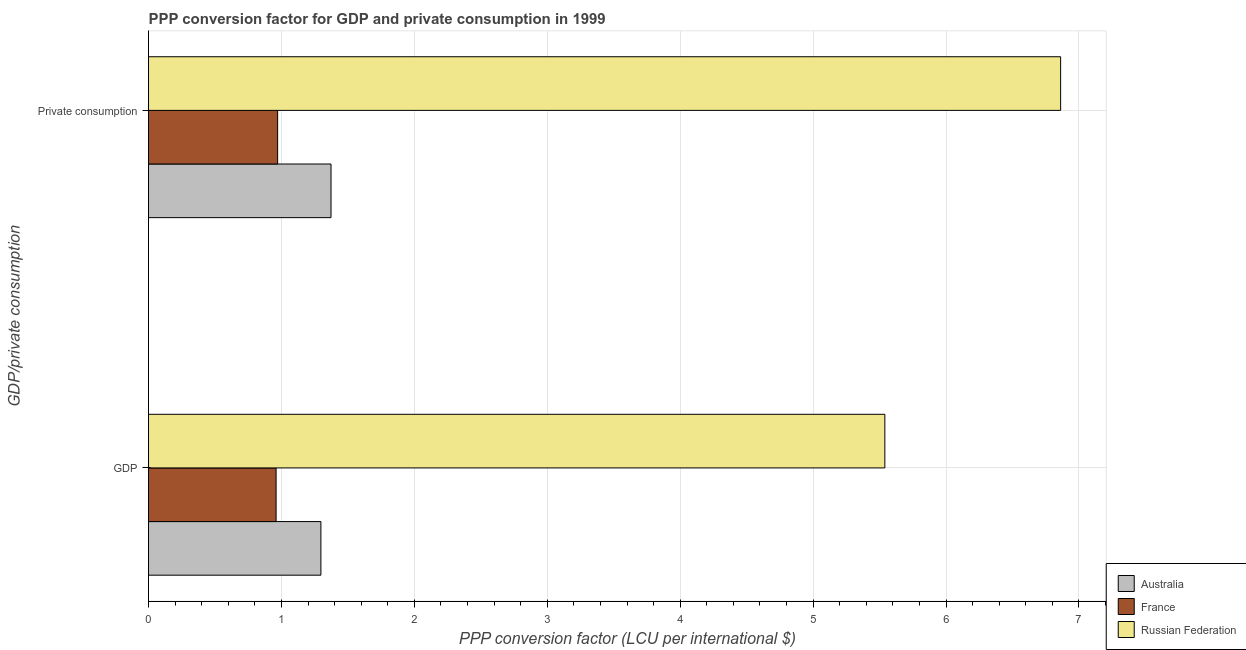How many groups of bars are there?
Your answer should be very brief. 2. Are the number of bars per tick equal to the number of legend labels?
Make the answer very short. Yes. How many bars are there on the 1st tick from the bottom?
Provide a succinct answer. 3. What is the label of the 2nd group of bars from the top?
Make the answer very short. GDP. What is the ppp conversion factor for gdp in France?
Offer a terse response. 0.96. Across all countries, what is the maximum ppp conversion factor for private consumption?
Offer a terse response. 6.86. Across all countries, what is the minimum ppp conversion factor for gdp?
Provide a succinct answer. 0.96. In which country was the ppp conversion factor for gdp maximum?
Keep it short and to the point. Russian Federation. In which country was the ppp conversion factor for gdp minimum?
Provide a short and direct response. France. What is the total ppp conversion factor for gdp in the graph?
Provide a short and direct response. 7.8. What is the difference between the ppp conversion factor for gdp in France and that in Russian Federation?
Provide a succinct answer. -4.58. What is the difference between the ppp conversion factor for gdp in Australia and the ppp conversion factor for private consumption in Russian Federation?
Provide a short and direct response. -5.57. What is the average ppp conversion factor for gdp per country?
Your answer should be compact. 2.6. What is the difference between the ppp conversion factor for gdp and ppp conversion factor for private consumption in Russian Federation?
Make the answer very short. -1.32. What is the ratio of the ppp conversion factor for private consumption in France to that in Australia?
Your answer should be compact. 0.71. In how many countries, is the ppp conversion factor for gdp greater than the average ppp conversion factor for gdp taken over all countries?
Provide a short and direct response. 1. What does the 2nd bar from the top in GDP represents?
Offer a terse response. France. How many countries are there in the graph?
Provide a succinct answer. 3. What is the difference between two consecutive major ticks on the X-axis?
Give a very brief answer. 1. Does the graph contain grids?
Provide a succinct answer. Yes. How are the legend labels stacked?
Make the answer very short. Vertical. What is the title of the graph?
Ensure brevity in your answer.  PPP conversion factor for GDP and private consumption in 1999. Does "Faeroe Islands" appear as one of the legend labels in the graph?
Provide a succinct answer. No. What is the label or title of the X-axis?
Ensure brevity in your answer.  PPP conversion factor (LCU per international $). What is the label or title of the Y-axis?
Offer a very short reply. GDP/private consumption. What is the PPP conversion factor (LCU per international $) in Australia in GDP?
Provide a short and direct response. 1.3. What is the PPP conversion factor (LCU per international $) in France in GDP?
Keep it short and to the point. 0.96. What is the PPP conversion factor (LCU per international $) in Russian Federation in GDP?
Make the answer very short. 5.54. What is the PPP conversion factor (LCU per international $) of Australia in  Private consumption?
Your answer should be compact. 1.37. What is the PPP conversion factor (LCU per international $) of France in  Private consumption?
Provide a short and direct response. 0.97. What is the PPP conversion factor (LCU per international $) in Russian Federation in  Private consumption?
Ensure brevity in your answer.  6.86. Across all GDP/private consumption, what is the maximum PPP conversion factor (LCU per international $) in Australia?
Make the answer very short. 1.37. Across all GDP/private consumption, what is the maximum PPP conversion factor (LCU per international $) of France?
Ensure brevity in your answer.  0.97. Across all GDP/private consumption, what is the maximum PPP conversion factor (LCU per international $) in Russian Federation?
Provide a short and direct response. 6.86. Across all GDP/private consumption, what is the minimum PPP conversion factor (LCU per international $) in Australia?
Your answer should be very brief. 1.3. Across all GDP/private consumption, what is the minimum PPP conversion factor (LCU per international $) in France?
Provide a short and direct response. 0.96. Across all GDP/private consumption, what is the minimum PPP conversion factor (LCU per international $) in Russian Federation?
Provide a succinct answer. 5.54. What is the total PPP conversion factor (LCU per international $) of Australia in the graph?
Offer a terse response. 2.67. What is the total PPP conversion factor (LCU per international $) of France in the graph?
Your answer should be compact. 1.93. What is the total PPP conversion factor (LCU per international $) in Russian Federation in the graph?
Offer a very short reply. 12.4. What is the difference between the PPP conversion factor (LCU per international $) in Australia in GDP and that in  Private consumption?
Ensure brevity in your answer.  -0.08. What is the difference between the PPP conversion factor (LCU per international $) in France in GDP and that in  Private consumption?
Provide a succinct answer. -0.01. What is the difference between the PPP conversion factor (LCU per international $) in Russian Federation in GDP and that in  Private consumption?
Provide a succinct answer. -1.32. What is the difference between the PPP conversion factor (LCU per international $) in Australia in GDP and the PPP conversion factor (LCU per international $) in France in  Private consumption?
Keep it short and to the point. 0.33. What is the difference between the PPP conversion factor (LCU per international $) in Australia in GDP and the PPP conversion factor (LCU per international $) in Russian Federation in  Private consumption?
Offer a very short reply. -5.57. What is the difference between the PPP conversion factor (LCU per international $) in France in GDP and the PPP conversion factor (LCU per international $) in Russian Federation in  Private consumption?
Your response must be concise. -5.9. What is the average PPP conversion factor (LCU per international $) of Australia per GDP/private consumption?
Ensure brevity in your answer.  1.33. What is the average PPP conversion factor (LCU per international $) in France per GDP/private consumption?
Give a very brief answer. 0.97. What is the average PPP conversion factor (LCU per international $) in Russian Federation per GDP/private consumption?
Keep it short and to the point. 6.2. What is the difference between the PPP conversion factor (LCU per international $) of Australia and PPP conversion factor (LCU per international $) of France in GDP?
Provide a succinct answer. 0.34. What is the difference between the PPP conversion factor (LCU per international $) of Australia and PPP conversion factor (LCU per international $) of Russian Federation in GDP?
Your answer should be compact. -4.24. What is the difference between the PPP conversion factor (LCU per international $) of France and PPP conversion factor (LCU per international $) of Russian Federation in GDP?
Ensure brevity in your answer.  -4.58. What is the difference between the PPP conversion factor (LCU per international $) of Australia and PPP conversion factor (LCU per international $) of France in  Private consumption?
Provide a succinct answer. 0.4. What is the difference between the PPP conversion factor (LCU per international $) in Australia and PPP conversion factor (LCU per international $) in Russian Federation in  Private consumption?
Ensure brevity in your answer.  -5.49. What is the difference between the PPP conversion factor (LCU per international $) in France and PPP conversion factor (LCU per international $) in Russian Federation in  Private consumption?
Provide a succinct answer. -5.89. What is the ratio of the PPP conversion factor (LCU per international $) of Australia in GDP to that in  Private consumption?
Offer a terse response. 0.94. What is the ratio of the PPP conversion factor (LCU per international $) in France in GDP to that in  Private consumption?
Make the answer very short. 0.99. What is the ratio of the PPP conversion factor (LCU per international $) of Russian Federation in GDP to that in  Private consumption?
Your answer should be very brief. 0.81. What is the difference between the highest and the second highest PPP conversion factor (LCU per international $) of Australia?
Ensure brevity in your answer.  0.08. What is the difference between the highest and the second highest PPP conversion factor (LCU per international $) in France?
Your answer should be very brief. 0.01. What is the difference between the highest and the second highest PPP conversion factor (LCU per international $) of Russian Federation?
Make the answer very short. 1.32. What is the difference between the highest and the lowest PPP conversion factor (LCU per international $) in Australia?
Your response must be concise. 0.08. What is the difference between the highest and the lowest PPP conversion factor (LCU per international $) of France?
Keep it short and to the point. 0.01. What is the difference between the highest and the lowest PPP conversion factor (LCU per international $) of Russian Federation?
Offer a very short reply. 1.32. 